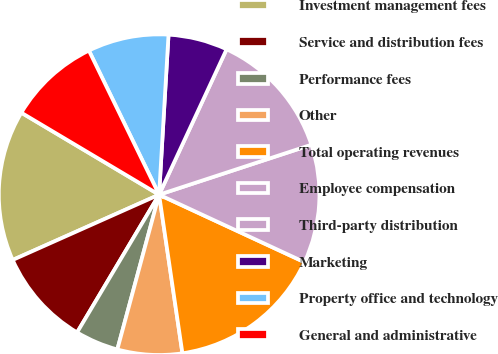Convert chart to OTSL. <chart><loc_0><loc_0><loc_500><loc_500><pie_chart><fcel>Investment management fees<fcel>Service and distribution fees<fcel>Performance fees<fcel>Other<fcel>Total operating revenues<fcel>Employee compensation<fcel>Third-party distribution<fcel>Marketing<fcel>Property office and technology<fcel>General and administrative<nl><fcel>15.22%<fcel>9.78%<fcel>4.35%<fcel>6.52%<fcel>15.76%<fcel>11.96%<fcel>13.04%<fcel>5.98%<fcel>8.15%<fcel>9.24%<nl></chart> 